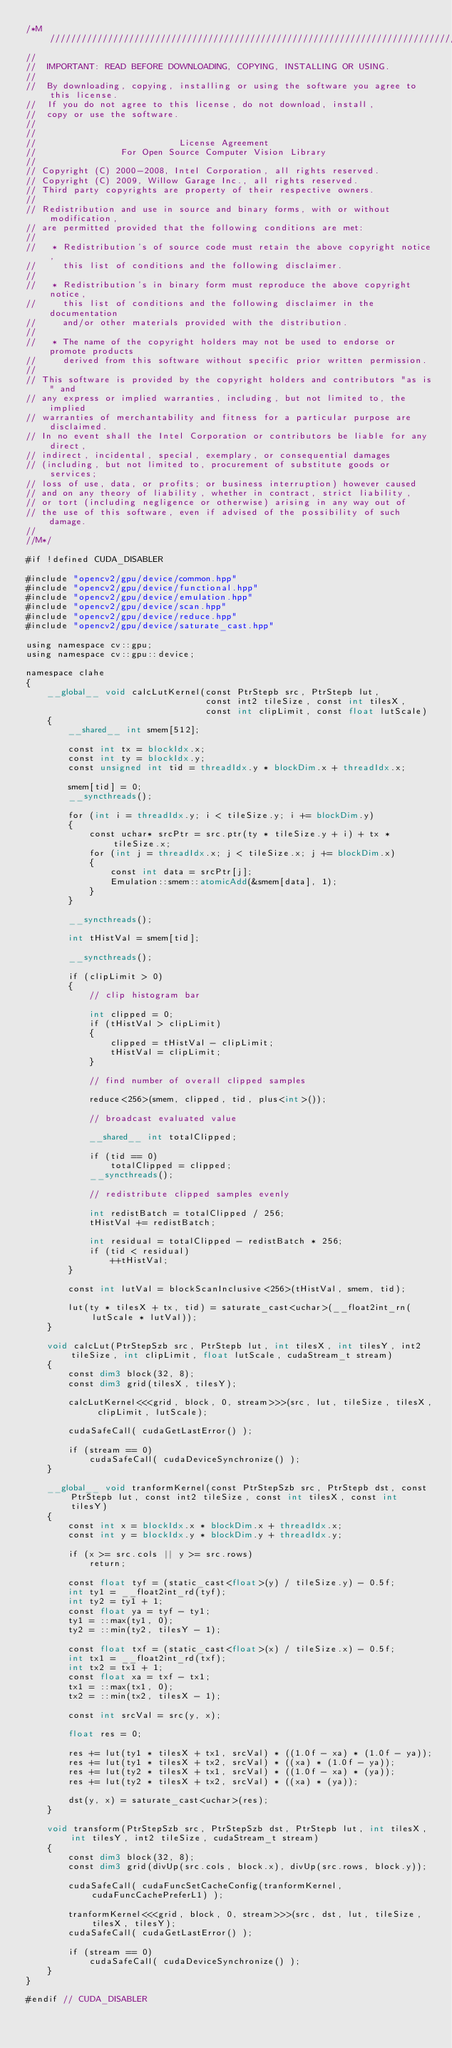<code> <loc_0><loc_0><loc_500><loc_500><_Cuda_>/*M///////////////////////////////////////////////////////////////////////////////////////
//
//  IMPORTANT: READ BEFORE DOWNLOADING, COPYING, INSTALLING OR USING.
//
//  By downloading, copying, installing or using the software you agree to this license.
//  If you do not agree to this license, do not download, install,
//  copy or use the software.
//
//
//                           License Agreement
//                For Open Source Computer Vision Library
//
// Copyright (C) 2000-2008, Intel Corporation, all rights reserved.
// Copyright (C) 2009, Willow Garage Inc., all rights reserved.
// Third party copyrights are property of their respective owners.
//
// Redistribution and use in source and binary forms, with or without modification,
// are permitted provided that the following conditions are met:
//
//   * Redistribution's of source code must retain the above copyright notice,
//     this list of conditions and the following disclaimer.
//
//   * Redistribution's in binary form must reproduce the above copyright notice,
//     this list of conditions and the following disclaimer in the documentation
//     and/or other materials provided with the distribution.
//
//   * The name of the copyright holders may not be used to endorse or promote products
//     derived from this software without specific prior written permission.
//
// This software is provided by the copyright holders and contributors "as is" and
// any express or implied warranties, including, but not limited to, the implied
// warranties of merchantability and fitness for a particular purpose are disclaimed.
// In no event shall the Intel Corporation or contributors be liable for any direct,
// indirect, incidental, special, exemplary, or consequential damages
// (including, but not limited to, procurement of substitute goods or services;
// loss of use, data, or profits; or business interruption) however caused
// and on any theory of liability, whether in contract, strict liability,
// or tort (including negligence or otherwise) arising in any way out of
// the use of this software, even if advised of the possibility of such damage.
//
//M*/

#if !defined CUDA_DISABLER

#include "opencv2/gpu/device/common.hpp"
#include "opencv2/gpu/device/functional.hpp"
#include "opencv2/gpu/device/emulation.hpp"
#include "opencv2/gpu/device/scan.hpp"
#include "opencv2/gpu/device/reduce.hpp"
#include "opencv2/gpu/device/saturate_cast.hpp"

using namespace cv::gpu;
using namespace cv::gpu::device;

namespace clahe
{
    __global__ void calcLutKernel(const PtrStepb src, PtrStepb lut,
                                  const int2 tileSize, const int tilesX,
                                  const int clipLimit, const float lutScale)
    {
        __shared__ int smem[512];

        const int tx = blockIdx.x;
        const int ty = blockIdx.y;
        const unsigned int tid = threadIdx.y * blockDim.x + threadIdx.x;

        smem[tid] = 0;
        __syncthreads();

        for (int i = threadIdx.y; i < tileSize.y; i += blockDim.y)
        {
            const uchar* srcPtr = src.ptr(ty * tileSize.y + i) + tx * tileSize.x;
            for (int j = threadIdx.x; j < tileSize.x; j += blockDim.x)
            {
                const int data = srcPtr[j];
                Emulation::smem::atomicAdd(&smem[data], 1);
            }
        }

        __syncthreads();

        int tHistVal = smem[tid];

        __syncthreads();

        if (clipLimit > 0)
        {
            // clip histogram bar

            int clipped = 0;
            if (tHistVal > clipLimit)
            {
                clipped = tHistVal - clipLimit;
                tHistVal = clipLimit;
            }

            // find number of overall clipped samples

            reduce<256>(smem, clipped, tid, plus<int>());

            // broadcast evaluated value

            __shared__ int totalClipped;

            if (tid == 0)
                totalClipped = clipped;
            __syncthreads();

            // redistribute clipped samples evenly

            int redistBatch = totalClipped / 256;
            tHistVal += redistBatch;

            int residual = totalClipped - redistBatch * 256;
            if (tid < residual)
                ++tHistVal;
        }

        const int lutVal = blockScanInclusive<256>(tHistVal, smem, tid);

        lut(ty * tilesX + tx, tid) = saturate_cast<uchar>(__float2int_rn(lutScale * lutVal));
    }

    void calcLut(PtrStepSzb src, PtrStepb lut, int tilesX, int tilesY, int2 tileSize, int clipLimit, float lutScale, cudaStream_t stream)
    {
        const dim3 block(32, 8);
        const dim3 grid(tilesX, tilesY);

        calcLutKernel<<<grid, block, 0, stream>>>(src, lut, tileSize, tilesX, clipLimit, lutScale);

        cudaSafeCall( cudaGetLastError() );

        if (stream == 0)
            cudaSafeCall( cudaDeviceSynchronize() );
    }

    __global__ void tranformKernel(const PtrStepSzb src, PtrStepb dst, const PtrStepb lut, const int2 tileSize, const int tilesX, const int tilesY)
    {
        const int x = blockIdx.x * blockDim.x + threadIdx.x;
        const int y = blockIdx.y * blockDim.y + threadIdx.y;

        if (x >= src.cols || y >= src.rows)
            return;

        const float tyf = (static_cast<float>(y) / tileSize.y) - 0.5f;
        int ty1 = __float2int_rd(tyf);
        int ty2 = ty1 + 1;
        const float ya = tyf - ty1;
        ty1 = ::max(ty1, 0);
        ty2 = ::min(ty2, tilesY - 1);

        const float txf = (static_cast<float>(x) / tileSize.x) - 0.5f;
        int tx1 = __float2int_rd(txf);
        int tx2 = tx1 + 1;
        const float xa = txf - tx1;
        tx1 = ::max(tx1, 0);
        tx2 = ::min(tx2, tilesX - 1);

        const int srcVal = src(y, x);

        float res = 0;

        res += lut(ty1 * tilesX + tx1, srcVal) * ((1.0f - xa) * (1.0f - ya));
        res += lut(ty1 * tilesX + tx2, srcVal) * ((xa) * (1.0f - ya));
        res += lut(ty2 * tilesX + tx1, srcVal) * ((1.0f - xa) * (ya));
        res += lut(ty2 * tilesX + tx2, srcVal) * ((xa) * (ya));

        dst(y, x) = saturate_cast<uchar>(res);
    }

    void transform(PtrStepSzb src, PtrStepSzb dst, PtrStepb lut, int tilesX, int tilesY, int2 tileSize, cudaStream_t stream)
    {
        const dim3 block(32, 8);
        const dim3 grid(divUp(src.cols, block.x), divUp(src.rows, block.y));

        cudaSafeCall( cudaFuncSetCacheConfig(tranformKernel, cudaFuncCachePreferL1) );

        tranformKernel<<<grid, block, 0, stream>>>(src, dst, lut, tileSize, tilesX, tilesY);
        cudaSafeCall( cudaGetLastError() );

        if (stream == 0)
            cudaSafeCall( cudaDeviceSynchronize() );
    }
}

#endif // CUDA_DISABLER
</code> 